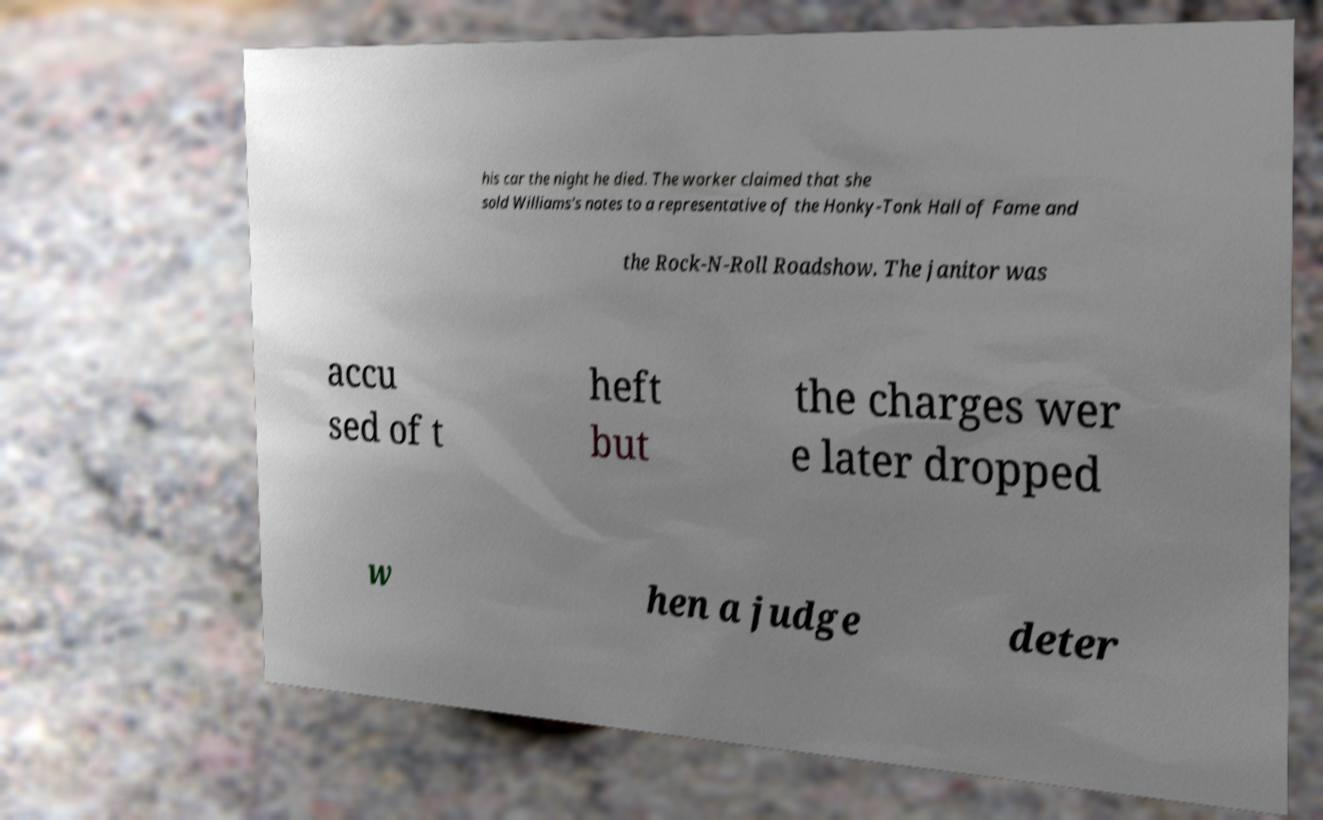Can you accurately transcribe the text from the provided image for me? his car the night he died. The worker claimed that she sold Williams's notes to a representative of the Honky-Tonk Hall of Fame and the Rock-N-Roll Roadshow. The janitor was accu sed of t heft but the charges wer e later dropped w hen a judge deter 